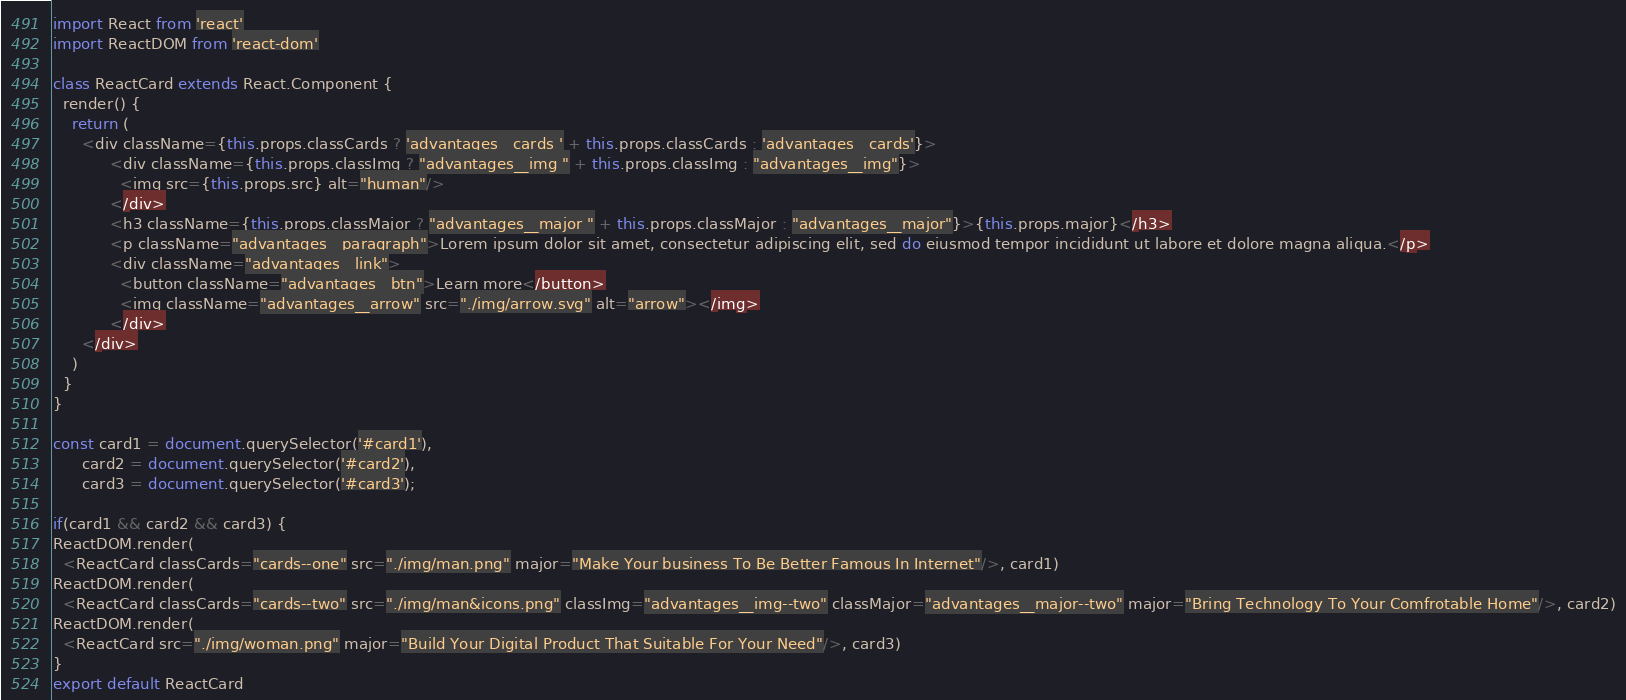Convert code to text. <code><loc_0><loc_0><loc_500><loc_500><_JavaScript_>import React from 'react'
import ReactDOM from 'react-dom'

class ReactCard extends React.Component {
  render() {
    return (
      <div className={this.props.classCards ? 'advantages__cards ' + this.props.classCards : 'advantages__cards'}>
            <div className={this.props.classImg ? "advantages__img " + this.props.classImg : "advantages__img"}>
              <img src={this.props.src} alt="human"/>
            </div>
            <h3 className={this.props.classMajor ? "advantages__major " + this.props.classMajor : "advantages__major"}>{this.props.major}</h3>
            <p className="advantages__paragraph">Lorem ipsum dolor sit amet, consectetur adipiscing elit, sed do eiusmod tempor incididunt ut labore et dolore magna aliqua.</p>
            <div className="advantages__link">
              <button className="advantages__btn">Learn more</button>
              <img className="advantages__arrow" src="./img/arrow.svg" alt="arrow"></img>
            </div>
      </div>
    )
  }
}

const card1 = document.querySelector('#card1'),
      card2 = document.querySelector('#card2'),
      card3 = document.querySelector('#card3');

if(card1 && card2 && card3) {
ReactDOM.render(
  <ReactCard classCards="cards--one" src="./img/man.png" major="Make Your business To Be Better Famous In Internet"/>, card1)
ReactDOM.render(
  <ReactCard classCards="cards--two" src="./img/man&icons.png" classImg="advantages__img--two" classMajor="advantages__major--two" major="Bring Technology To Your Comfrotable Home"/>, card2)
ReactDOM.render(
  <ReactCard src="./img/woman.png" major="Build Your Digital Product That Suitable For Your Need"/>, card3)
}
export default ReactCard
</code> 